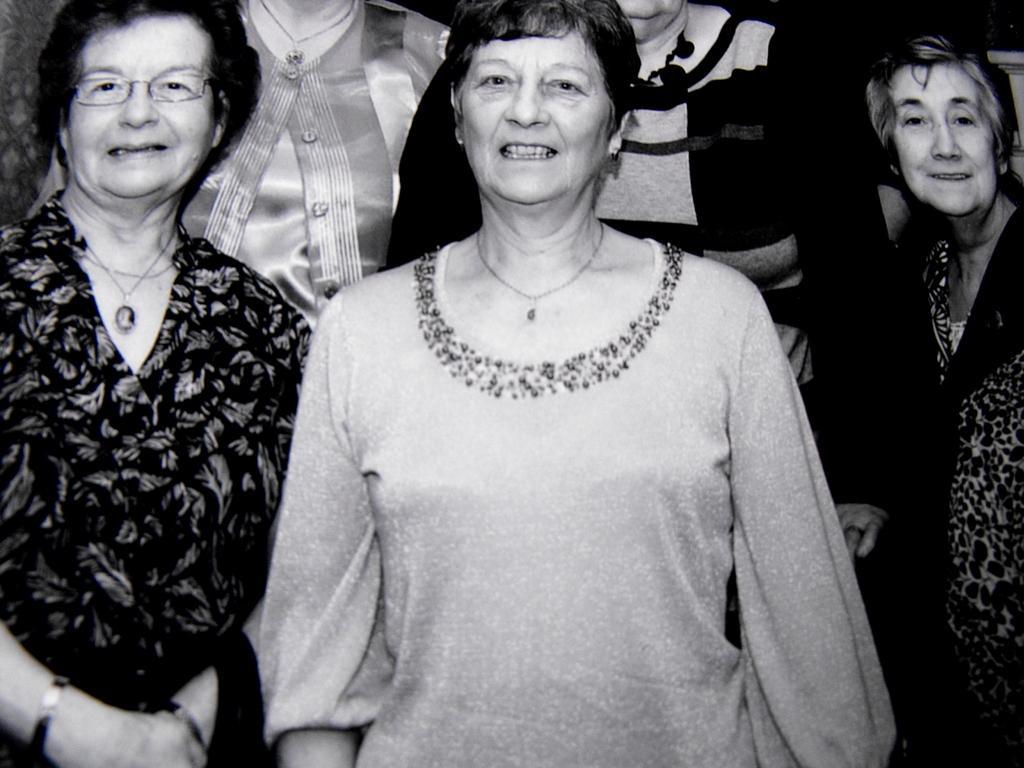Can you describe this image briefly? This is a black and white image. In this picture we can see five ladies are standing and wearing dresses. 